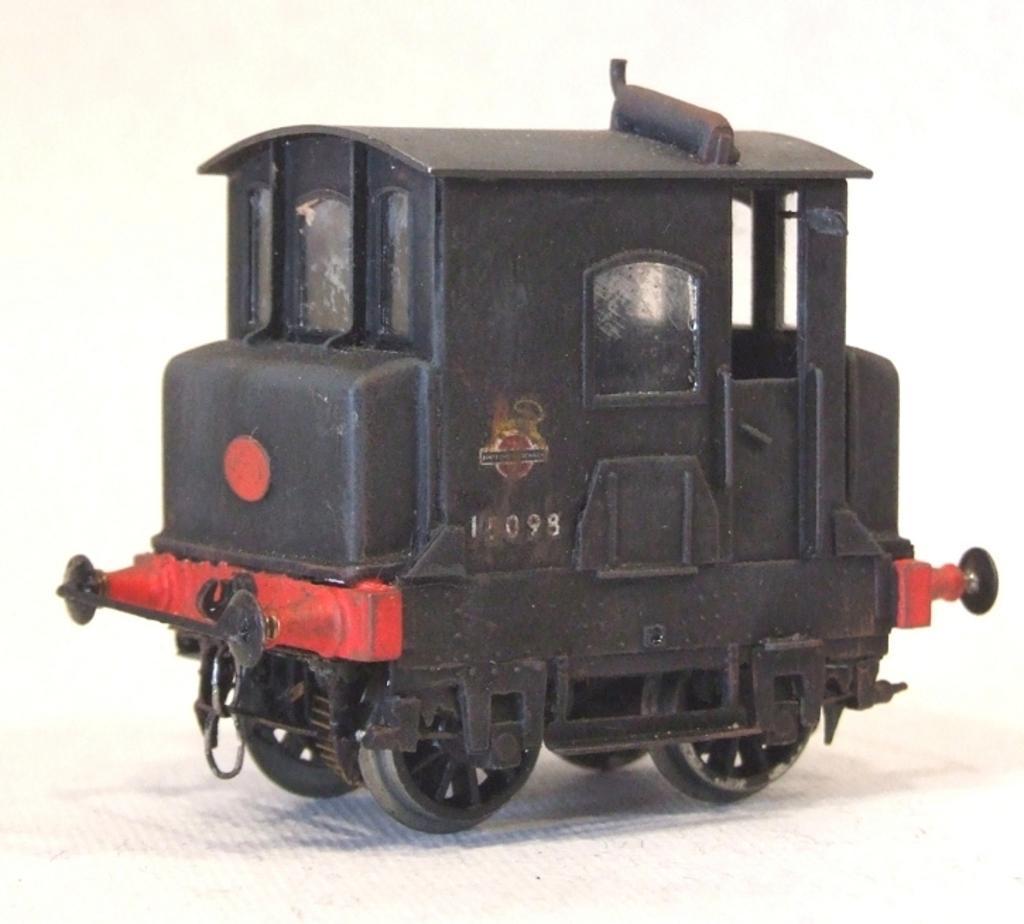In one or two sentences, can you explain what this image depicts? As we can see in the image there is a black color vehicle. 